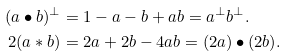<formula> <loc_0><loc_0><loc_500><loc_500>( a \bullet b ) ^ { \perp } & = 1 - a - b + a b = a ^ { \perp } b ^ { \perp } . \\ 2 ( a * b ) & = 2 a + 2 b - 4 a b = ( 2 a ) \bullet ( 2 b ) .</formula> 